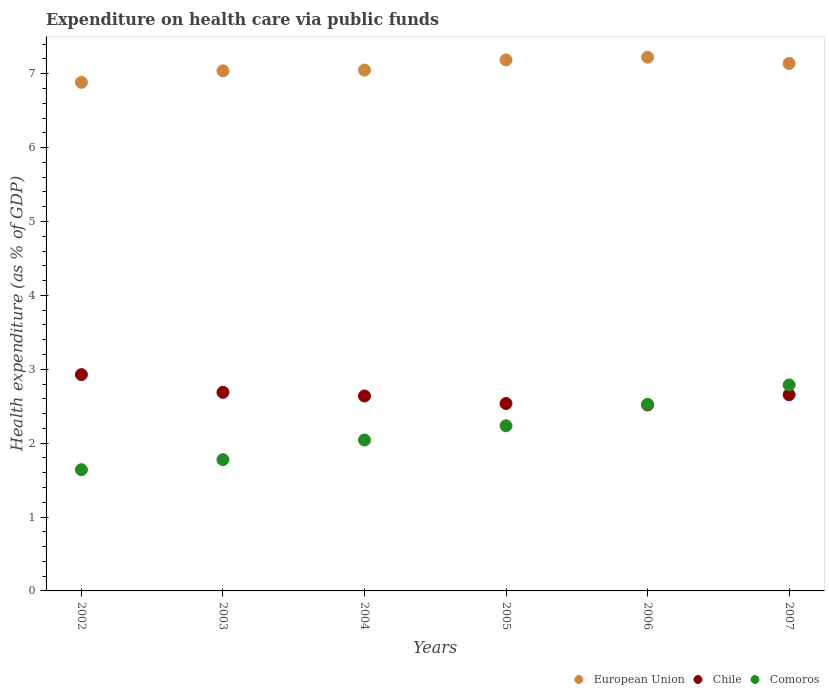How many different coloured dotlines are there?
Your answer should be compact. 3. What is the expenditure made on health care in European Union in 2004?
Your answer should be compact. 7.05. Across all years, what is the maximum expenditure made on health care in Comoros?
Your answer should be very brief. 2.79. Across all years, what is the minimum expenditure made on health care in European Union?
Your answer should be compact. 6.88. In which year was the expenditure made on health care in Chile maximum?
Offer a very short reply. 2002. What is the total expenditure made on health care in Comoros in the graph?
Make the answer very short. 13.01. What is the difference between the expenditure made on health care in Chile in 2004 and that in 2005?
Keep it short and to the point. 0.1. What is the difference between the expenditure made on health care in Comoros in 2006 and the expenditure made on health care in European Union in 2007?
Make the answer very short. -4.61. What is the average expenditure made on health care in Comoros per year?
Provide a succinct answer. 2.17. In the year 2006, what is the difference between the expenditure made on health care in Chile and expenditure made on health care in Comoros?
Provide a succinct answer. -0.01. What is the ratio of the expenditure made on health care in European Union in 2004 to that in 2006?
Your answer should be compact. 0.98. Is the expenditure made on health care in European Union in 2004 less than that in 2007?
Make the answer very short. Yes. Is the difference between the expenditure made on health care in Chile in 2002 and 2005 greater than the difference between the expenditure made on health care in Comoros in 2002 and 2005?
Provide a succinct answer. Yes. What is the difference between the highest and the second highest expenditure made on health care in Chile?
Provide a short and direct response. 0.24. What is the difference between the highest and the lowest expenditure made on health care in Comoros?
Your answer should be compact. 1.15. In how many years, is the expenditure made on health care in European Union greater than the average expenditure made on health care in European Union taken over all years?
Make the answer very short. 3. Is the sum of the expenditure made on health care in Chile in 2006 and 2007 greater than the maximum expenditure made on health care in Comoros across all years?
Give a very brief answer. Yes. Does the expenditure made on health care in Comoros monotonically increase over the years?
Offer a terse response. Yes. How many dotlines are there?
Your answer should be very brief. 3. Does the graph contain grids?
Provide a succinct answer. No. Where does the legend appear in the graph?
Offer a terse response. Bottom right. How are the legend labels stacked?
Your response must be concise. Horizontal. What is the title of the graph?
Keep it short and to the point. Expenditure on health care via public funds. What is the label or title of the X-axis?
Provide a succinct answer. Years. What is the label or title of the Y-axis?
Give a very brief answer. Health expenditure (as % of GDP). What is the Health expenditure (as % of GDP) of European Union in 2002?
Offer a terse response. 6.88. What is the Health expenditure (as % of GDP) of Chile in 2002?
Your answer should be compact. 2.93. What is the Health expenditure (as % of GDP) of Comoros in 2002?
Offer a very short reply. 1.64. What is the Health expenditure (as % of GDP) of European Union in 2003?
Make the answer very short. 7.04. What is the Health expenditure (as % of GDP) of Chile in 2003?
Your response must be concise. 2.69. What is the Health expenditure (as % of GDP) of Comoros in 2003?
Your answer should be compact. 1.78. What is the Health expenditure (as % of GDP) in European Union in 2004?
Your response must be concise. 7.05. What is the Health expenditure (as % of GDP) in Chile in 2004?
Your answer should be very brief. 2.64. What is the Health expenditure (as % of GDP) in Comoros in 2004?
Keep it short and to the point. 2.04. What is the Health expenditure (as % of GDP) in European Union in 2005?
Keep it short and to the point. 7.19. What is the Health expenditure (as % of GDP) in Chile in 2005?
Ensure brevity in your answer.  2.54. What is the Health expenditure (as % of GDP) of Comoros in 2005?
Your response must be concise. 2.23. What is the Health expenditure (as % of GDP) of European Union in 2006?
Offer a terse response. 7.22. What is the Health expenditure (as % of GDP) of Chile in 2006?
Ensure brevity in your answer.  2.52. What is the Health expenditure (as % of GDP) of Comoros in 2006?
Offer a terse response. 2.53. What is the Health expenditure (as % of GDP) in European Union in 2007?
Your response must be concise. 7.14. What is the Health expenditure (as % of GDP) of Chile in 2007?
Give a very brief answer. 2.66. What is the Health expenditure (as % of GDP) in Comoros in 2007?
Provide a succinct answer. 2.79. Across all years, what is the maximum Health expenditure (as % of GDP) of European Union?
Offer a terse response. 7.22. Across all years, what is the maximum Health expenditure (as % of GDP) of Chile?
Provide a short and direct response. 2.93. Across all years, what is the maximum Health expenditure (as % of GDP) of Comoros?
Keep it short and to the point. 2.79. Across all years, what is the minimum Health expenditure (as % of GDP) in European Union?
Give a very brief answer. 6.88. Across all years, what is the minimum Health expenditure (as % of GDP) of Chile?
Your response must be concise. 2.52. Across all years, what is the minimum Health expenditure (as % of GDP) of Comoros?
Ensure brevity in your answer.  1.64. What is the total Health expenditure (as % of GDP) in European Union in the graph?
Give a very brief answer. 42.52. What is the total Health expenditure (as % of GDP) of Chile in the graph?
Your response must be concise. 15.96. What is the total Health expenditure (as % of GDP) in Comoros in the graph?
Give a very brief answer. 13.01. What is the difference between the Health expenditure (as % of GDP) of European Union in 2002 and that in 2003?
Offer a very short reply. -0.16. What is the difference between the Health expenditure (as % of GDP) in Chile in 2002 and that in 2003?
Your response must be concise. 0.24. What is the difference between the Health expenditure (as % of GDP) of Comoros in 2002 and that in 2003?
Your answer should be very brief. -0.14. What is the difference between the Health expenditure (as % of GDP) of European Union in 2002 and that in 2004?
Ensure brevity in your answer.  -0.17. What is the difference between the Health expenditure (as % of GDP) of Chile in 2002 and that in 2004?
Keep it short and to the point. 0.29. What is the difference between the Health expenditure (as % of GDP) in Comoros in 2002 and that in 2004?
Keep it short and to the point. -0.4. What is the difference between the Health expenditure (as % of GDP) in European Union in 2002 and that in 2005?
Your answer should be very brief. -0.3. What is the difference between the Health expenditure (as % of GDP) in Chile in 2002 and that in 2005?
Keep it short and to the point. 0.39. What is the difference between the Health expenditure (as % of GDP) of Comoros in 2002 and that in 2005?
Your answer should be compact. -0.59. What is the difference between the Health expenditure (as % of GDP) of European Union in 2002 and that in 2006?
Offer a very short reply. -0.34. What is the difference between the Health expenditure (as % of GDP) in Chile in 2002 and that in 2006?
Provide a succinct answer. 0.41. What is the difference between the Health expenditure (as % of GDP) of Comoros in 2002 and that in 2006?
Provide a short and direct response. -0.89. What is the difference between the Health expenditure (as % of GDP) of European Union in 2002 and that in 2007?
Offer a very short reply. -0.26. What is the difference between the Health expenditure (as % of GDP) of Chile in 2002 and that in 2007?
Give a very brief answer. 0.27. What is the difference between the Health expenditure (as % of GDP) of Comoros in 2002 and that in 2007?
Your response must be concise. -1.15. What is the difference between the Health expenditure (as % of GDP) of European Union in 2003 and that in 2004?
Your answer should be compact. -0.01. What is the difference between the Health expenditure (as % of GDP) of Chile in 2003 and that in 2004?
Your response must be concise. 0.05. What is the difference between the Health expenditure (as % of GDP) in Comoros in 2003 and that in 2004?
Give a very brief answer. -0.27. What is the difference between the Health expenditure (as % of GDP) of European Union in 2003 and that in 2005?
Give a very brief answer. -0.15. What is the difference between the Health expenditure (as % of GDP) in Chile in 2003 and that in 2005?
Offer a terse response. 0.15. What is the difference between the Health expenditure (as % of GDP) of Comoros in 2003 and that in 2005?
Your answer should be compact. -0.46. What is the difference between the Health expenditure (as % of GDP) of European Union in 2003 and that in 2006?
Make the answer very short. -0.18. What is the difference between the Health expenditure (as % of GDP) of Chile in 2003 and that in 2006?
Offer a terse response. 0.17. What is the difference between the Health expenditure (as % of GDP) of Comoros in 2003 and that in 2006?
Keep it short and to the point. -0.75. What is the difference between the Health expenditure (as % of GDP) in European Union in 2003 and that in 2007?
Offer a terse response. -0.1. What is the difference between the Health expenditure (as % of GDP) in Chile in 2003 and that in 2007?
Ensure brevity in your answer.  0.03. What is the difference between the Health expenditure (as % of GDP) of Comoros in 2003 and that in 2007?
Ensure brevity in your answer.  -1.01. What is the difference between the Health expenditure (as % of GDP) of European Union in 2004 and that in 2005?
Your answer should be compact. -0.14. What is the difference between the Health expenditure (as % of GDP) in Chile in 2004 and that in 2005?
Offer a terse response. 0.1. What is the difference between the Health expenditure (as % of GDP) of Comoros in 2004 and that in 2005?
Your answer should be very brief. -0.19. What is the difference between the Health expenditure (as % of GDP) of European Union in 2004 and that in 2006?
Ensure brevity in your answer.  -0.17. What is the difference between the Health expenditure (as % of GDP) in Chile in 2004 and that in 2006?
Your answer should be very brief. 0.12. What is the difference between the Health expenditure (as % of GDP) of Comoros in 2004 and that in 2006?
Ensure brevity in your answer.  -0.48. What is the difference between the Health expenditure (as % of GDP) in European Union in 2004 and that in 2007?
Keep it short and to the point. -0.09. What is the difference between the Health expenditure (as % of GDP) of Chile in 2004 and that in 2007?
Ensure brevity in your answer.  -0.02. What is the difference between the Health expenditure (as % of GDP) in Comoros in 2004 and that in 2007?
Your response must be concise. -0.75. What is the difference between the Health expenditure (as % of GDP) in European Union in 2005 and that in 2006?
Your response must be concise. -0.04. What is the difference between the Health expenditure (as % of GDP) in Chile in 2005 and that in 2006?
Your response must be concise. 0.02. What is the difference between the Health expenditure (as % of GDP) in Comoros in 2005 and that in 2006?
Give a very brief answer. -0.29. What is the difference between the Health expenditure (as % of GDP) in European Union in 2005 and that in 2007?
Your answer should be compact. 0.05. What is the difference between the Health expenditure (as % of GDP) in Chile in 2005 and that in 2007?
Ensure brevity in your answer.  -0.12. What is the difference between the Health expenditure (as % of GDP) in Comoros in 2005 and that in 2007?
Make the answer very short. -0.55. What is the difference between the Health expenditure (as % of GDP) in European Union in 2006 and that in 2007?
Your response must be concise. 0.09. What is the difference between the Health expenditure (as % of GDP) of Chile in 2006 and that in 2007?
Ensure brevity in your answer.  -0.14. What is the difference between the Health expenditure (as % of GDP) in Comoros in 2006 and that in 2007?
Provide a succinct answer. -0.26. What is the difference between the Health expenditure (as % of GDP) of European Union in 2002 and the Health expenditure (as % of GDP) of Chile in 2003?
Offer a terse response. 4.2. What is the difference between the Health expenditure (as % of GDP) of European Union in 2002 and the Health expenditure (as % of GDP) of Comoros in 2003?
Your answer should be very brief. 5.11. What is the difference between the Health expenditure (as % of GDP) in Chile in 2002 and the Health expenditure (as % of GDP) in Comoros in 2003?
Keep it short and to the point. 1.15. What is the difference between the Health expenditure (as % of GDP) of European Union in 2002 and the Health expenditure (as % of GDP) of Chile in 2004?
Provide a succinct answer. 4.24. What is the difference between the Health expenditure (as % of GDP) of European Union in 2002 and the Health expenditure (as % of GDP) of Comoros in 2004?
Your response must be concise. 4.84. What is the difference between the Health expenditure (as % of GDP) of Chile in 2002 and the Health expenditure (as % of GDP) of Comoros in 2004?
Offer a terse response. 0.89. What is the difference between the Health expenditure (as % of GDP) of European Union in 2002 and the Health expenditure (as % of GDP) of Chile in 2005?
Offer a terse response. 4.35. What is the difference between the Health expenditure (as % of GDP) of European Union in 2002 and the Health expenditure (as % of GDP) of Comoros in 2005?
Your answer should be very brief. 4.65. What is the difference between the Health expenditure (as % of GDP) of Chile in 2002 and the Health expenditure (as % of GDP) of Comoros in 2005?
Offer a very short reply. 0.69. What is the difference between the Health expenditure (as % of GDP) in European Union in 2002 and the Health expenditure (as % of GDP) in Chile in 2006?
Offer a terse response. 4.37. What is the difference between the Health expenditure (as % of GDP) of European Union in 2002 and the Health expenditure (as % of GDP) of Comoros in 2006?
Provide a succinct answer. 4.36. What is the difference between the Health expenditure (as % of GDP) in Chile in 2002 and the Health expenditure (as % of GDP) in Comoros in 2006?
Make the answer very short. 0.4. What is the difference between the Health expenditure (as % of GDP) of European Union in 2002 and the Health expenditure (as % of GDP) of Chile in 2007?
Provide a succinct answer. 4.23. What is the difference between the Health expenditure (as % of GDP) in European Union in 2002 and the Health expenditure (as % of GDP) in Comoros in 2007?
Give a very brief answer. 4.1. What is the difference between the Health expenditure (as % of GDP) in Chile in 2002 and the Health expenditure (as % of GDP) in Comoros in 2007?
Give a very brief answer. 0.14. What is the difference between the Health expenditure (as % of GDP) of European Union in 2003 and the Health expenditure (as % of GDP) of Chile in 2004?
Make the answer very short. 4.4. What is the difference between the Health expenditure (as % of GDP) in European Union in 2003 and the Health expenditure (as % of GDP) in Comoros in 2004?
Offer a terse response. 5. What is the difference between the Health expenditure (as % of GDP) of Chile in 2003 and the Health expenditure (as % of GDP) of Comoros in 2004?
Offer a very short reply. 0.65. What is the difference between the Health expenditure (as % of GDP) of European Union in 2003 and the Health expenditure (as % of GDP) of Chile in 2005?
Provide a succinct answer. 4.5. What is the difference between the Health expenditure (as % of GDP) of European Union in 2003 and the Health expenditure (as % of GDP) of Comoros in 2005?
Your response must be concise. 4.8. What is the difference between the Health expenditure (as % of GDP) in Chile in 2003 and the Health expenditure (as % of GDP) in Comoros in 2005?
Give a very brief answer. 0.45. What is the difference between the Health expenditure (as % of GDP) in European Union in 2003 and the Health expenditure (as % of GDP) in Chile in 2006?
Make the answer very short. 4.52. What is the difference between the Health expenditure (as % of GDP) of European Union in 2003 and the Health expenditure (as % of GDP) of Comoros in 2006?
Give a very brief answer. 4.51. What is the difference between the Health expenditure (as % of GDP) in Chile in 2003 and the Health expenditure (as % of GDP) in Comoros in 2006?
Offer a terse response. 0.16. What is the difference between the Health expenditure (as % of GDP) of European Union in 2003 and the Health expenditure (as % of GDP) of Chile in 2007?
Provide a short and direct response. 4.38. What is the difference between the Health expenditure (as % of GDP) of European Union in 2003 and the Health expenditure (as % of GDP) of Comoros in 2007?
Offer a terse response. 4.25. What is the difference between the Health expenditure (as % of GDP) in Chile in 2003 and the Health expenditure (as % of GDP) in Comoros in 2007?
Provide a short and direct response. -0.1. What is the difference between the Health expenditure (as % of GDP) in European Union in 2004 and the Health expenditure (as % of GDP) in Chile in 2005?
Provide a short and direct response. 4.51. What is the difference between the Health expenditure (as % of GDP) in European Union in 2004 and the Health expenditure (as % of GDP) in Comoros in 2005?
Make the answer very short. 4.81. What is the difference between the Health expenditure (as % of GDP) in Chile in 2004 and the Health expenditure (as % of GDP) in Comoros in 2005?
Your answer should be very brief. 0.4. What is the difference between the Health expenditure (as % of GDP) in European Union in 2004 and the Health expenditure (as % of GDP) in Chile in 2006?
Your answer should be very brief. 4.53. What is the difference between the Health expenditure (as % of GDP) in European Union in 2004 and the Health expenditure (as % of GDP) in Comoros in 2006?
Offer a very short reply. 4.52. What is the difference between the Health expenditure (as % of GDP) of Chile in 2004 and the Health expenditure (as % of GDP) of Comoros in 2006?
Give a very brief answer. 0.11. What is the difference between the Health expenditure (as % of GDP) of European Union in 2004 and the Health expenditure (as % of GDP) of Chile in 2007?
Ensure brevity in your answer.  4.39. What is the difference between the Health expenditure (as % of GDP) of European Union in 2004 and the Health expenditure (as % of GDP) of Comoros in 2007?
Make the answer very short. 4.26. What is the difference between the Health expenditure (as % of GDP) in Chile in 2004 and the Health expenditure (as % of GDP) in Comoros in 2007?
Provide a succinct answer. -0.15. What is the difference between the Health expenditure (as % of GDP) in European Union in 2005 and the Health expenditure (as % of GDP) in Chile in 2006?
Offer a very short reply. 4.67. What is the difference between the Health expenditure (as % of GDP) of European Union in 2005 and the Health expenditure (as % of GDP) of Comoros in 2006?
Ensure brevity in your answer.  4.66. What is the difference between the Health expenditure (as % of GDP) of Chile in 2005 and the Health expenditure (as % of GDP) of Comoros in 2006?
Offer a terse response. 0.01. What is the difference between the Health expenditure (as % of GDP) of European Union in 2005 and the Health expenditure (as % of GDP) of Chile in 2007?
Ensure brevity in your answer.  4.53. What is the difference between the Health expenditure (as % of GDP) in European Union in 2005 and the Health expenditure (as % of GDP) in Comoros in 2007?
Provide a succinct answer. 4.4. What is the difference between the Health expenditure (as % of GDP) of Chile in 2005 and the Health expenditure (as % of GDP) of Comoros in 2007?
Offer a very short reply. -0.25. What is the difference between the Health expenditure (as % of GDP) of European Union in 2006 and the Health expenditure (as % of GDP) of Chile in 2007?
Your answer should be compact. 4.57. What is the difference between the Health expenditure (as % of GDP) of European Union in 2006 and the Health expenditure (as % of GDP) of Comoros in 2007?
Provide a short and direct response. 4.44. What is the difference between the Health expenditure (as % of GDP) of Chile in 2006 and the Health expenditure (as % of GDP) of Comoros in 2007?
Offer a terse response. -0.27. What is the average Health expenditure (as % of GDP) of European Union per year?
Your answer should be very brief. 7.09. What is the average Health expenditure (as % of GDP) in Chile per year?
Your answer should be very brief. 2.66. What is the average Health expenditure (as % of GDP) in Comoros per year?
Ensure brevity in your answer.  2.17. In the year 2002, what is the difference between the Health expenditure (as % of GDP) of European Union and Health expenditure (as % of GDP) of Chile?
Ensure brevity in your answer.  3.96. In the year 2002, what is the difference between the Health expenditure (as % of GDP) of European Union and Health expenditure (as % of GDP) of Comoros?
Provide a succinct answer. 5.24. In the year 2002, what is the difference between the Health expenditure (as % of GDP) of Chile and Health expenditure (as % of GDP) of Comoros?
Ensure brevity in your answer.  1.29. In the year 2003, what is the difference between the Health expenditure (as % of GDP) in European Union and Health expenditure (as % of GDP) in Chile?
Provide a short and direct response. 4.35. In the year 2003, what is the difference between the Health expenditure (as % of GDP) in European Union and Health expenditure (as % of GDP) in Comoros?
Ensure brevity in your answer.  5.26. In the year 2003, what is the difference between the Health expenditure (as % of GDP) in Chile and Health expenditure (as % of GDP) in Comoros?
Ensure brevity in your answer.  0.91. In the year 2004, what is the difference between the Health expenditure (as % of GDP) in European Union and Health expenditure (as % of GDP) in Chile?
Provide a short and direct response. 4.41. In the year 2004, what is the difference between the Health expenditure (as % of GDP) of European Union and Health expenditure (as % of GDP) of Comoros?
Your answer should be very brief. 5.01. In the year 2004, what is the difference between the Health expenditure (as % of GDP) of Chile and Health expenditure (as % of GDP) of Comoros?
Make the answer very short. 0.6. In the year 2005, what is the difference between the Health expenditure (as % of GDP) of European Union and Health expenditure (as % of GDP) of Chile?
Provide a succinct answer. 4.65. In the year 2005, what is the difference between the Health expenditure (as % of GDP) in European Union and Health expenditure (as % of GDP) in Comoros?
Make the answer very short. 4.95. In the year 2005, what is the difference between the Health expenditure (as % of GDP) in Chile and Health expenditure (as % of GDP) in Comoros?
Ensure brevity in your answer.  0.3. In the year 2006, what is the difference between the Health expenditure (as % of GDP) of European Union and Health expenditure (as % of GDP) of Chile?
Your response must be concise. 4.71. In the year 2006, what is the difference between the Health expenditure (as % of GDP) of European Union and Health expenditure (as % of GDP) of Comoros?
Keep it short and to the point. 4.7. In the year 2006, what is the difference between the Health expenditure (as % of GDP) of Chile and Health expenditure (as % of GDP) of Comoros?
Keep it short and to the point. -0.01. In the year 2007, what is the difference between the Health expenditure (as % of GDP) in European Union and Health expenditure (as % of GDP) in Chile?
Make the answer very short. 4.48. In the year 2007, what is the difference between the Health expenditure (as % of GDP) in European Union and Health expenditure (as % of GDP) in Comoros?
Your answer should be compact. 4.35. In the year 2007, what is the difference between the Health expenditure (as % of GDP) of Chile and Health expenditure (as % of GDP) of Comoros?
Your response must be concise. -0.13. What is the ratio of the Health expenditure (as % of GDP) in European Union in 2002 to that in 2003?
Make the answer very short. 0.98. What is the ratio of the Health expenditure (as % of GDP) in Chile in 2002 to that in 2003?
Provide a short and direct response. 1.09. What is the ratio of the Health expenditure (as % of GDP) in Comoros in 2002 to that in 2003?
Offer a terse response. 0.92. What is the ratio of the Health expenditure (as % of GDP) in European Union in 2002 to that in 2004?
Your answer should be very brief. 0.98. What is the ratio of the Health expenditure (as % of GDP) in Chile in 2002 to that in 2004?
Your response must be concise. 1.11. What is the ratio of the Health expenditure (as % of GDP) of Comoros in 2002 to that in 2004?
Offer a terse response. 0.8. What is the ratio of the Health expenditure (as % of GDP) in European Union in 2002 to that in 2005?
Offer a terse response. 0.96. What is the ratio of the Health expenditure (as % of GDP) in Chile in 2002 to that in 2005?
Your answer should be very brief. 1.15. What is the ratio of the Health expenditure (as % of GDP) in Comoros in 2002 to that in 2005?
Ensure brevity in your answer.  0.73. What is the ratio of the Health expenditure (as % of GDP) of European Union in 2002 to that in 2006?
Your answer should be compact. 0.95. What is the ratio of the Health expenditure (as % of GDP) in Chile in 2002 to that in 2006?
Offer a very short reply. 1.16. What is the ratio of the Health expenditure (as % of GDP) of Comoros in 2002 to that in 2006?
Keep it short and to the point. 0.65. What is the ratio of the Health expenditure (as % of GDP) of European Union in 2002 to that in 2007?
Your answer should be very brief. 0.96. What is the ratio of the Health expenditure (as % of GDP) in Chile in 2002 to that in 2007?
Provide a succinct answer. 1.1. What is the ratio of the Health expenditure (as % of GDP) in Comoros in 2002 to that in 2007?
Your answer should be very brief. 0.59. What is the ratio of the Health expenditure (as % of GDP) in Chile in 2003 to that in 2004?
Your answer should be very brief. 1.02. What is the ratio of the Health expenditure (as % of GDP) of Comoros in 2003 to that in 2004?
Give a very brief answer. 0.87. What is the ratio of the Health expenditure (as % of GDP) in European Union in 2003 to that in 2005?
Ensure brevity in your answer.  0.98. What is the ratio of the Health expenditure (as % of GDP) of Chile in 2003 to that in 2005?
Provide a short and direct response. 1.06. What is the ratio of the Health expenditure (as % of GDP) of Comoros in 2003 to that in 2005?
Your answer should be very brief. 0.8. What is the ratio of the Health expenditure (as % of GDP) in European Union in 2003 to that in 2006?
Give a very brief answer. 0.97. What is the ratio of the Health expenditure (as % of GDP) in Chile in 2003 to that in 2006?
Give a very brief answer. 1.07. What is the ratio of the Health expenditure (as % of GDP) in Comoros in 2003 to that in 2006?
Provide a short and direct response. 0.7. What is the ratio of the Health expenditure (as % of GDP) of European Union in 2003 to that in 2007?
Make the answer very short. 0.99. What is the ratio of the Health expenditure (as % of GDP) in Chile in 2003 to that in 2007?
Ensure brevity in your answer.  1.01. What is the ratio of the Health expenditure (as % of GDP) of Comoros in 2003 to that in 2007?
Your answer should be very brief. 0.64. What is the ratio of the Health expenditure (as % of GDP) in European Union in 2004 to that in 2005?
Ensure brevity in your answer.  0.98. What is the ratio of the Health expenditure (as % of GDP) in Chile in 2004 to that in 2005?
Your answer should be very brief. 1.04. What is the ratio of the Health expenditure (as % of GDP) of Comoros in 2004 to that in 2005?
Keep it short and to the point. 0.91. What is the ratio of the Health expenditure (as % of GDP) in European Union in 2004 to that in 2006?
Your answer should be compact. 0.98. What is the ratio of the Health expenditure (as % of GDP) of Chile in 2004 to that in 2006?
Offer a very short reply. 1.05. What is the ratio of the Health expenditure (as % of GDP) in Comoros in 2004 to that in 2006?
Your response must be concise. 0.81. What is the ratio of the Health expenditure (as % of GDP) in European Union in 2004 to that in 2007?
Provide a short and direct response. 0.99. What is the ratio of the Health expenditure (as % of GDP) in Comoros in 2004 to that in 2007?
Offer a very short reply. 0.73. What is the ratio of the Health expenditure (as % of GDP) of Chile in 2005 to that in 2006?
Ensure brevity in your answer.  1.01. What is the ratio of the Health expenditure (as % of GDP) of Comoros in 2005 to that in 2006?
Make the answer very short. 0.89. What is the ratio of the Health expenditure (as % of GDP) in European Union in 2005 to that in 2007?
Your response must be concise. 1.01. What is the ratio of the Health expenditure (as % of GDP) in Chile in 2005 to that in 2007?
Keep it short and to the point. 0.96. What is the ratio of the Health expenditure (as % of GDP) in Comoros in 2005 to that in 2007?
Offer a terse response. 0.8. What is the ratio of the Health expenditure (as % of GDP) of European Union in 2006 to that in 2007?
Give a very brief answer. 1.01. What is the ratio of the Health expenditure (as % of GDP) in Chile in 2006 to that in 2007?
Ensure brevity in your answer.  0.95. What is the ratio of the Health expenditure (as % of GDP) in Comoros in 2006 to that in 2007?
Keep it short and to the point. 0.91. What is the difference between the highest and the second highest Health expenditure (as % of GDP) in European Union?
Make the answer very short. 0.04. What is the difference between the highest and the second highest Health expenditure (as % of GDP) of Chile?
Make the answer very short. 0.24. What is the difference between the highest and the second highest Health expenditure (as % of GDP) of Comoros?
Offer a very short reply. 0.26. What is the difference between the highest and the lowest Health expenditure (as % of GDP) of European Union?
Ensure brevity in your answer.  0.34. What is the difference between the highest and the lowest Health expenditure (as % of GDP) in Chile?
Provide a succinct answer. 0.41. What is the difference between the highest and the lowest Health expenditure (as % of GDP) in Comoros?
Your answer should be compact. 1.15. 